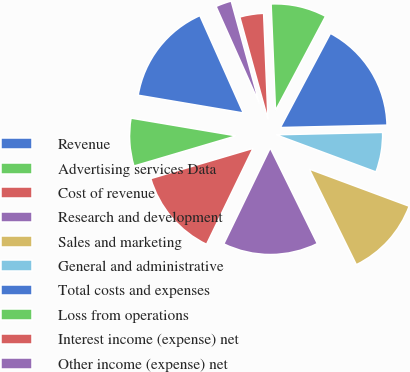Convert chart. <chart><loc_0><loc_0><loc_500><loc_500><pie_chart><fcel>Revenue<fcel>Advertising services Data<fcel>Cost of revenue<fcel>Research and development<fcel>Sales and marketing<fcel>General and administrative<fcel>Total costs and expenses<fcel>Loss from operations<fcel>Interest income (expense) net<fcel>Other income (expense) net<nl><fcel>15.66%<fcel>7.23%<fcel>13.25%<fcel>14.46%<fcel>12.05%<fcel>6.02%<fcel>16.87%<fcel>8.43%<fcel>3.61%<fcel>2.41%<nl></chart> 